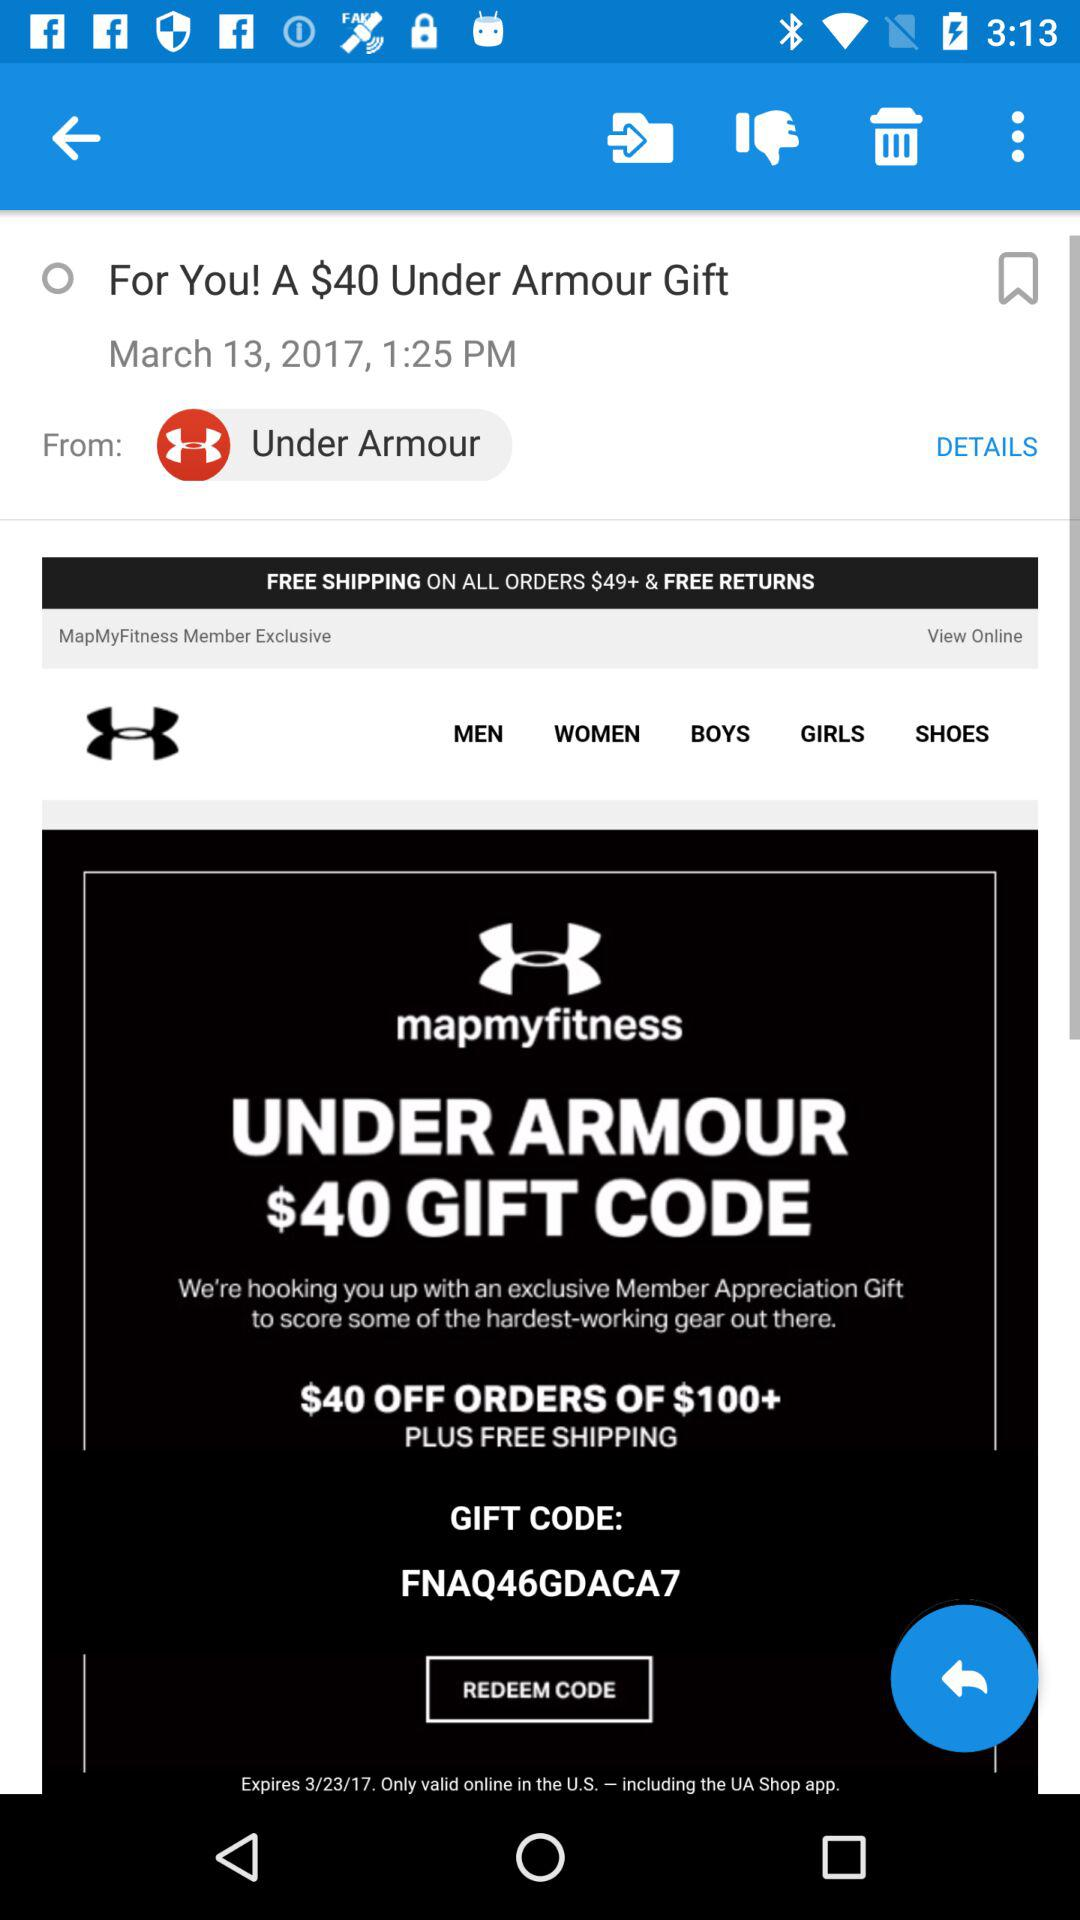How much discount can I get using the under armour gift code? You can get a discount of $40. 